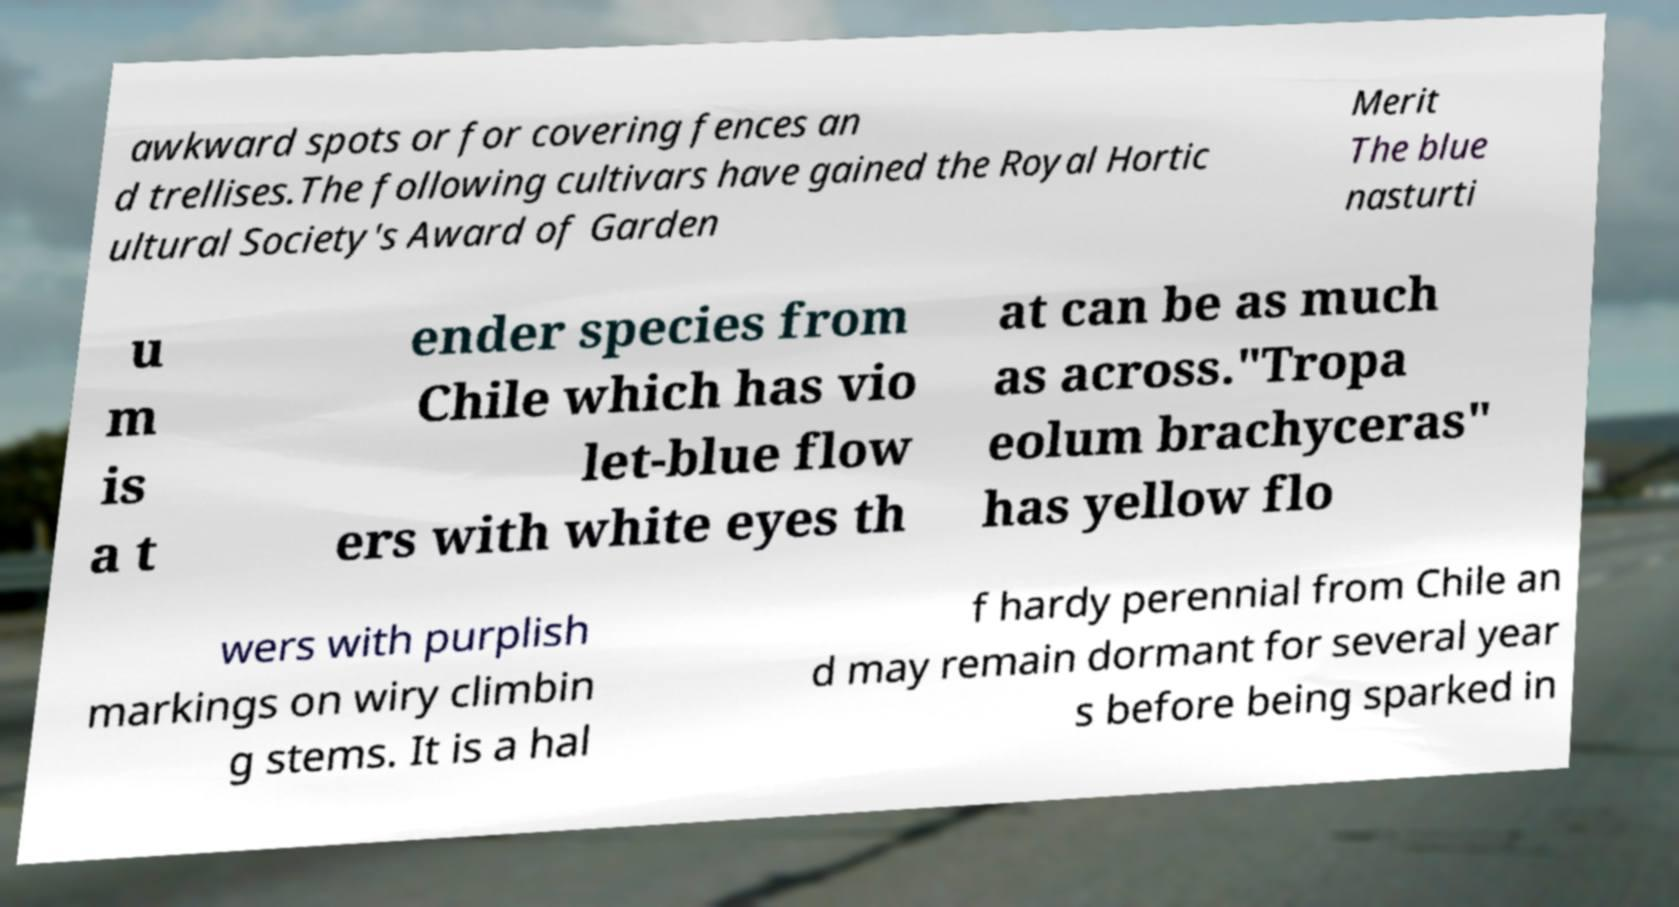Please identify and transcribe the text found in this image. awkward spots or for covering fences an d trellises.The following cultivars have gained the Royal Hortic ultural Society's Award of Garden Merit The blue nasturti u m is a t ender species from Chile which has vio let-blue flow ers with white eyes th at can be as much as across."Tropa eolum brachyceras" has yellow flo wers with purplish markings on wiry climbin g stems. It is a hal f hardy perennial from Chile an d may remain dormant for several year s before being sparked in 